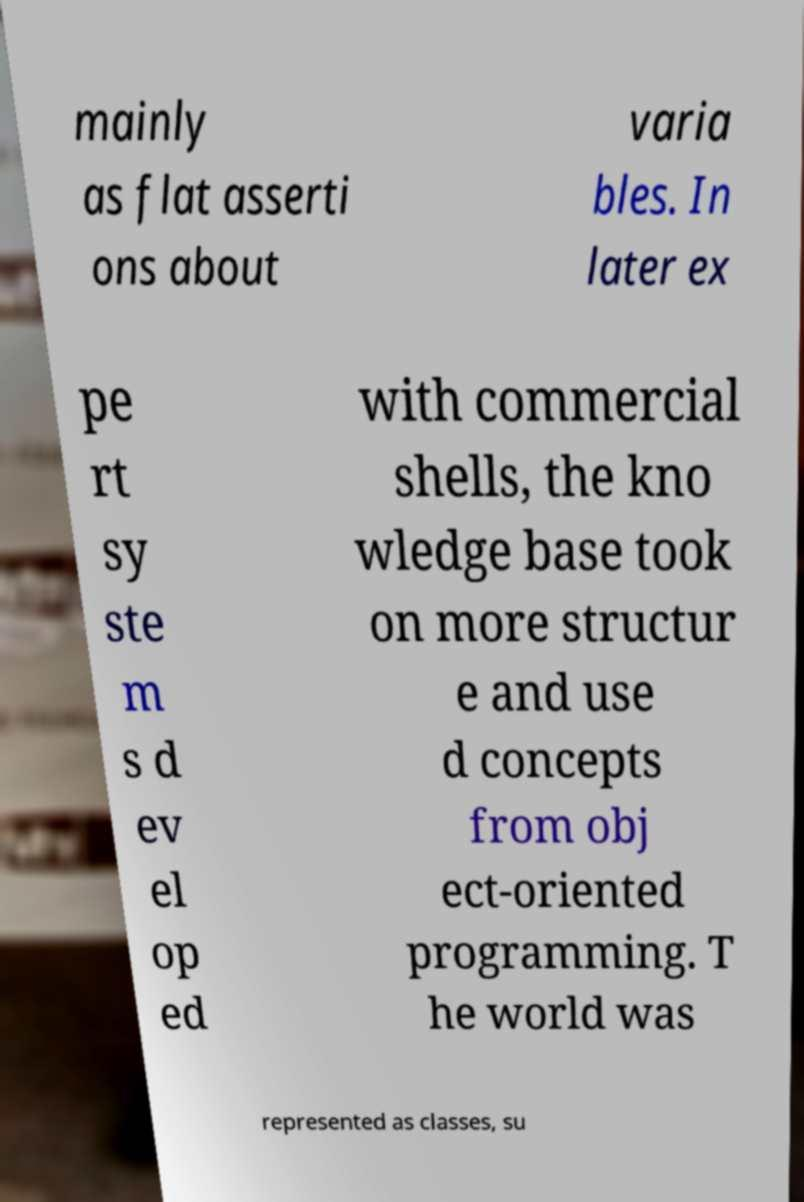There's text embedded in this image that I need extracted. Can you transcribe it verbatim? mainly as flat asserti ons about varia bles. In later ex pe rt sy ste m s d ev el op ed with commercial shells, the kno wledge base took on more structur e and use d concepts from obj ect-oriented programming. T he world was represented as classes, su 